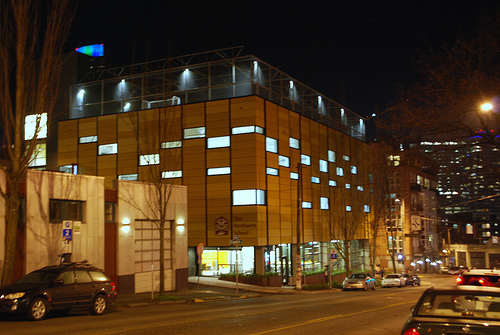<image>
Is the sky behind the light? Yes. From this viewpoint, the sky is positioned behind the light, with the light partially or fully occluding the sky. 